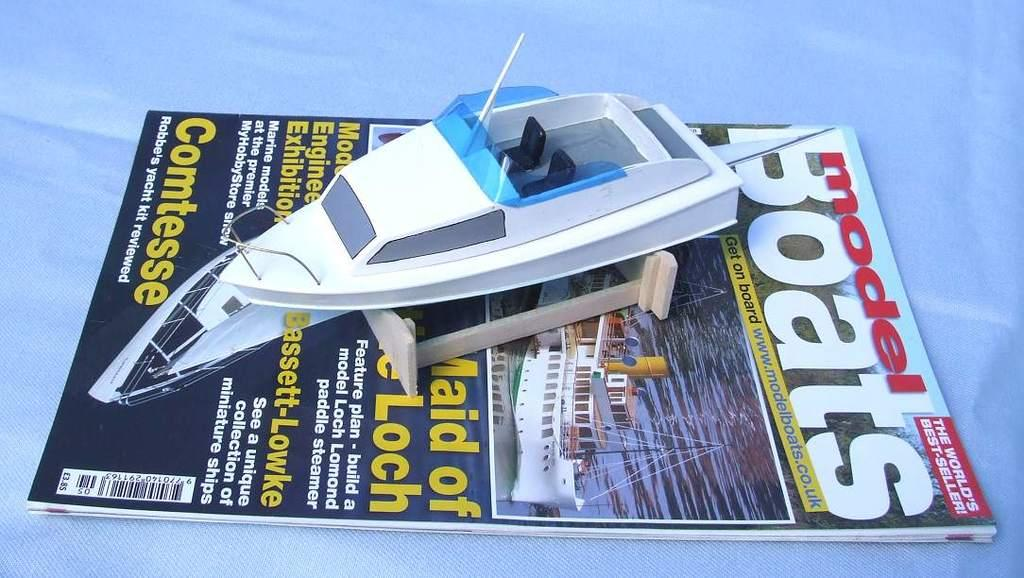<image>
Share a concise interpretation of the image provided. the word boats that is on a magazine 